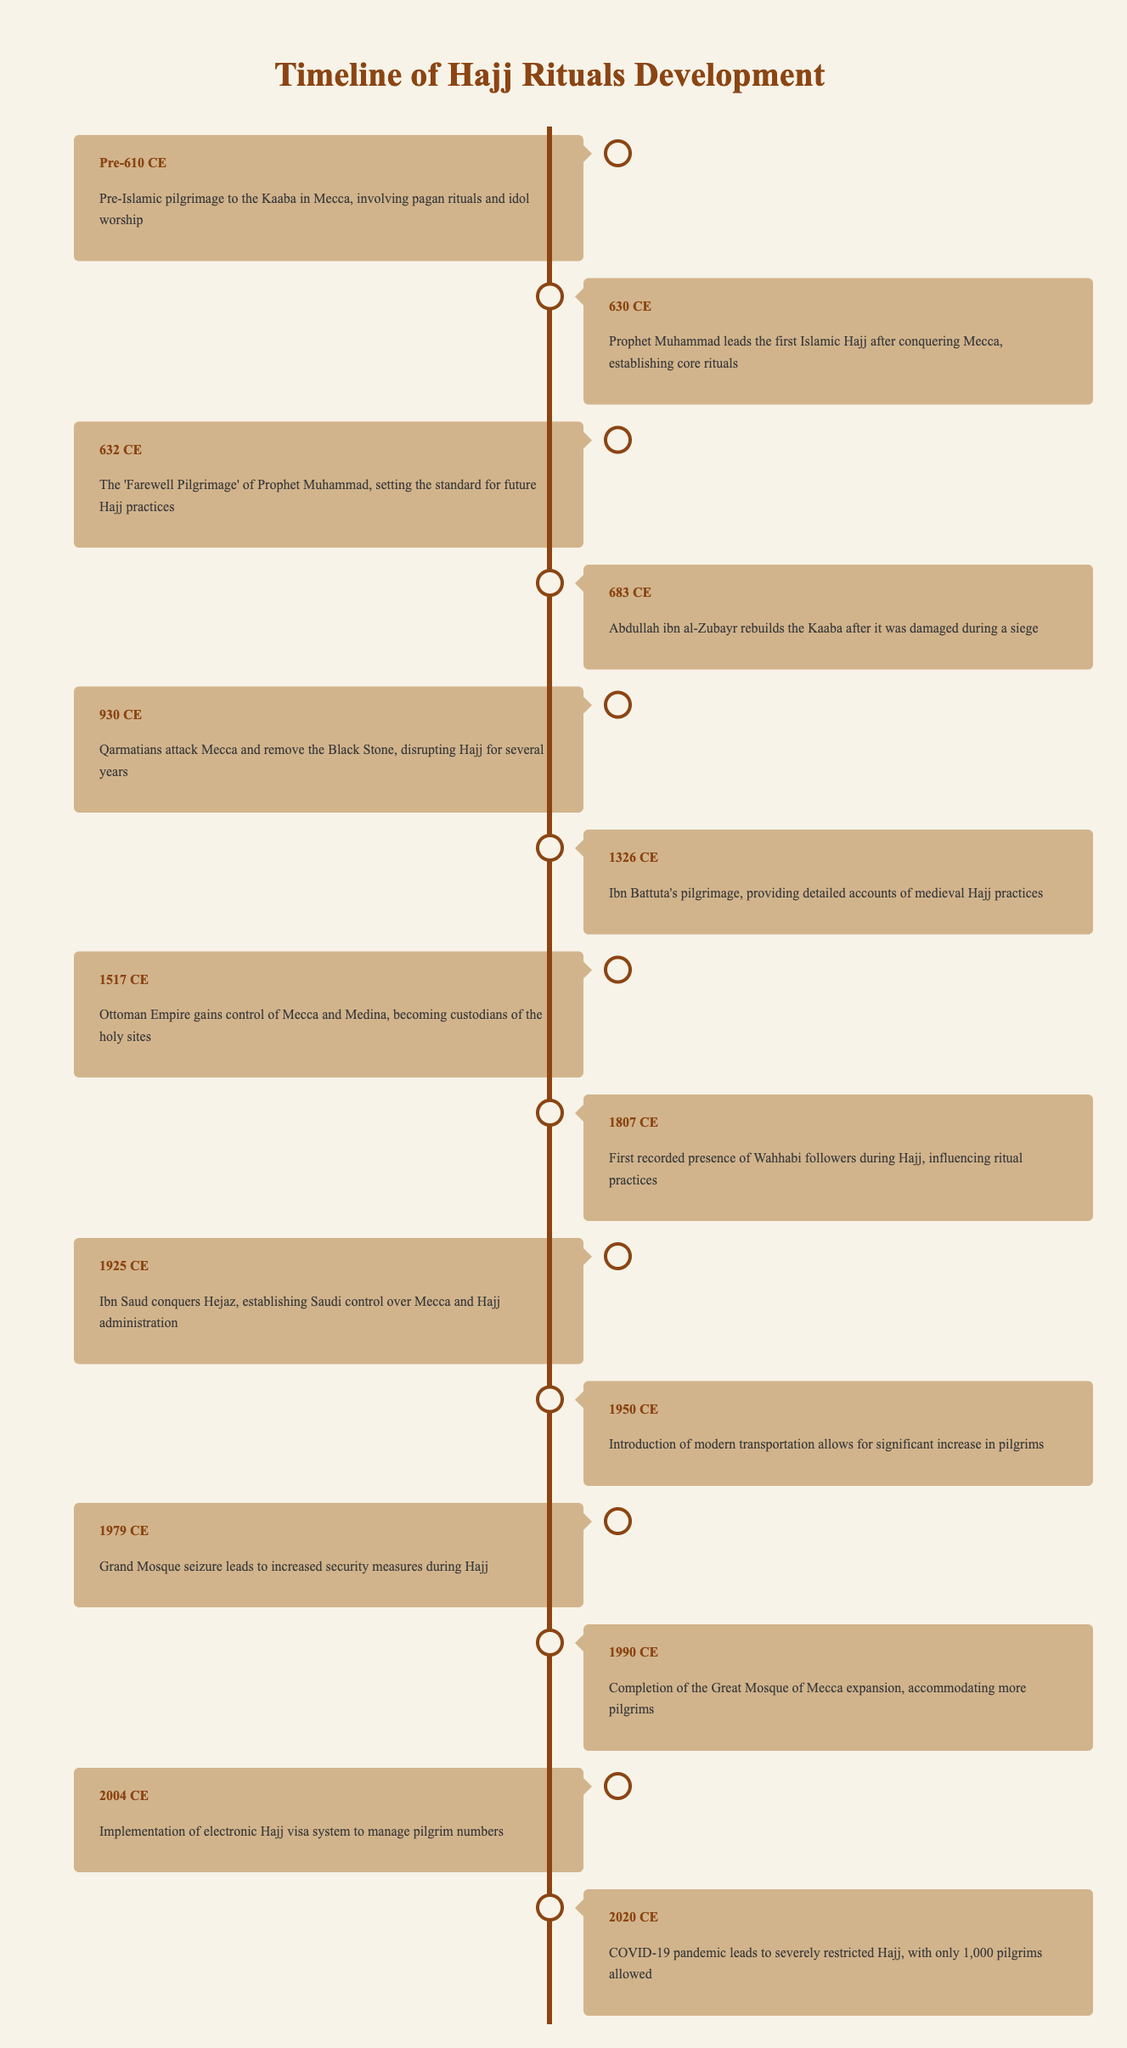What was the event that occurred in 632 CE? According to the table, in 632 CE, the event was "The 'Farewell Pilgrimage' of Prophet Muhammad, setting the standard for future Hajj practices."
Answer: The 'Farewell Pilgrimage' of Prophet Muhammad What significant event disrupted Hajj for several years in 930 CE? The table states that in 930 CE, the "Qarmatians attack Mecca and remove the Black Stone, disrupting Hajj for several years" as the event, indicating the impact it had on pilgrimage practices.
Answer: Qarmatians attack Mecca and remove the Black Stone How many years passed between the first Islamic Hajj in 630 CE and the construction of the Great Mosque of Mecca expansion in 1990 CE? To find this, subtract 630 from 1990, which gives 1990 - 630 = 1360 years.
Answer: 1360 years Was Ibn Battuta's pilgrimage recorded in the timeline? Yes, the table confirms that there is an event labeled with Ibn Battuta's pilgrimage occurring in 1326 CE, indicating his significant contribution to documenting Hajj practices.
Answer: Yes What are the two events that resulted in changes to the administration of Hajj in the 20th century? The table identifies two events: in 1925 CE, "Ibn Saud conquers Hejaz, establishing Saudi control over Mecca and Hajj administration" and in 2004 CE, "Implementation of electronic Hajj visa system to manage pilgrim numbers." Therefore, these events illustrate the evolution of Hajj administration.
Answer: Ibn Saud's conquest and implementation of the electronic visa system What event caused an increase in pilgrims in 1950 CE? The entry for 1950 CE mentions "Introduction of modern transportation allows for significant increase in pilgrims," indicating that advancements in transport technology facilitated greater pilgrim numbers.
Answer: Introduction of modern transportation Compare the number of significant changes to Hajj rituals before the 1800s versus after. Looking at the table, before the 1800s (covering events up to 1807 CE), there are 8 key events listed. After 1807 CE, there are 7 key events listed through to 2020 CE. Thus, there were 8 changes before and 7 after.
Answer: 8 before, 7 after How did the events of 1979 CE impact security during Hajj? According to the table, in 1979 CE, the event was "Grand Mosque seizure leads to increased security measures during Hajj," which indicates a direct impact on Hajj security protocols due to heightened concerns after the event.
Answer: Increased security measures 